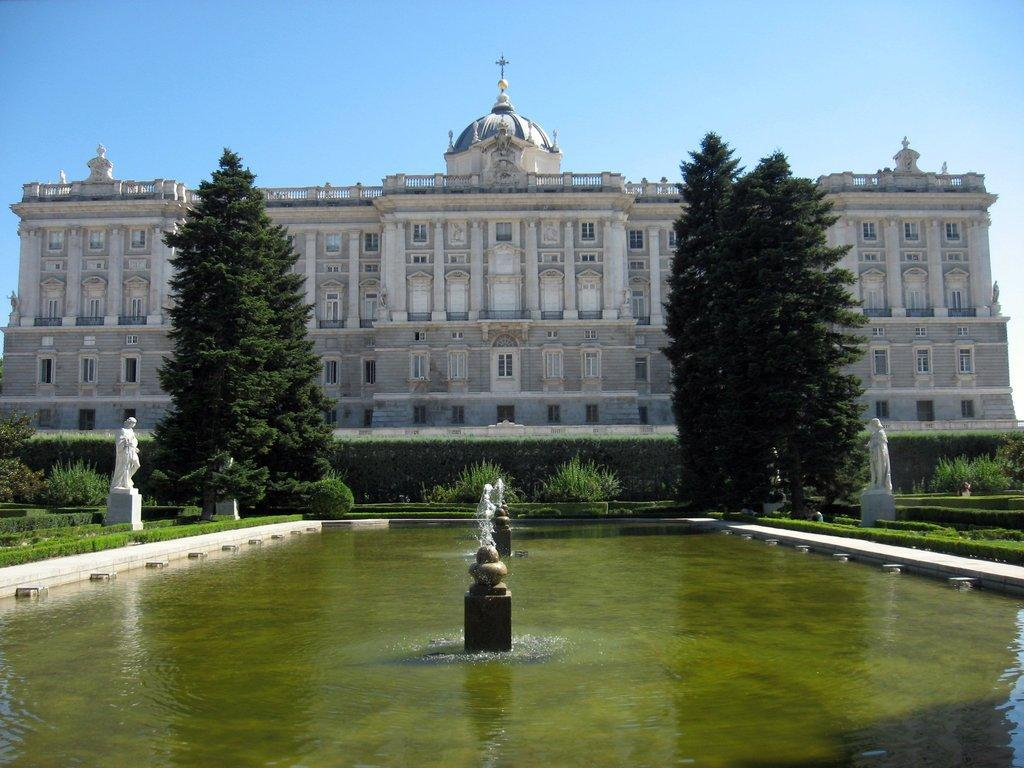What type of structure is present in the image? There is a building in the image. What natural elements can be seen in the image? There are trees, grass, and plants in the image. What man-made features are visible in the image? There are water fountains and sculptures in the image. What part of the natural environment is visible in the image? The sky is visible in the image. Can you see a donkey grazing on the grass in the image? There is no donkey present in the image. What type of cracker is being used to fold the sculptures in the image? There is no cracker or folding of sculptures depicted in the image. 